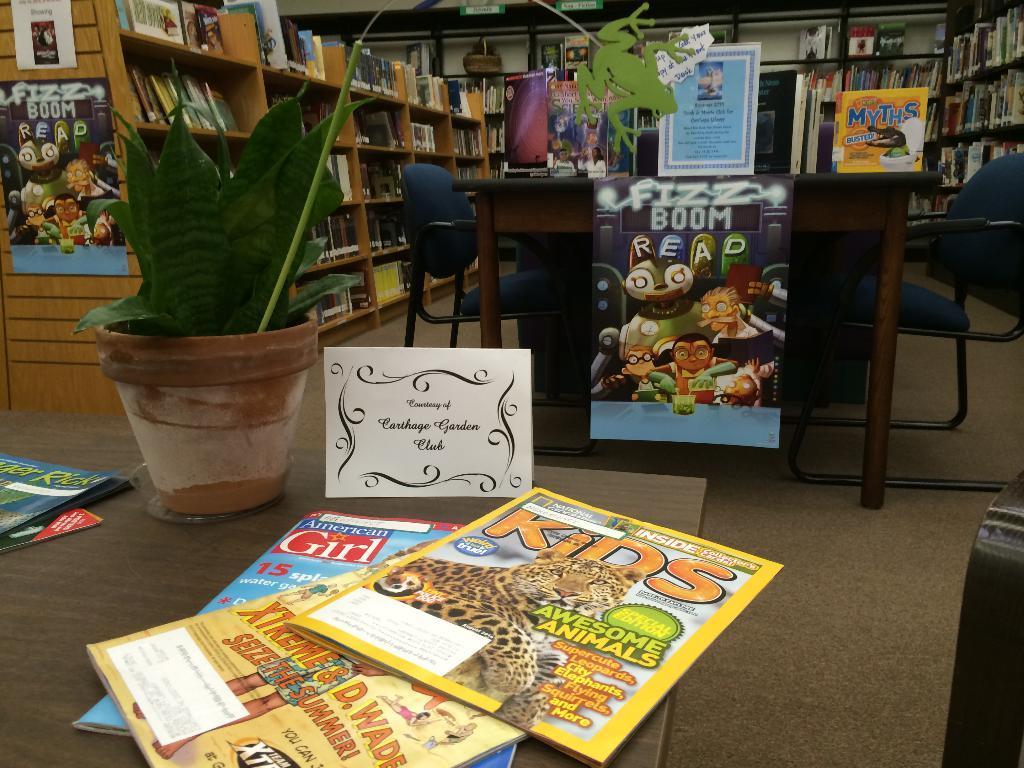Please provide a concise description of this image. In this picture we can see a table. On the table there are books and a plant. Here we can see chairs. On the background we can see a rack and there are some books in that. And this is floor. 